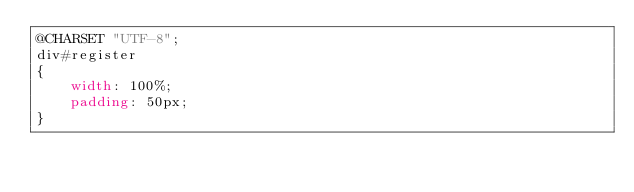<code> <loc_0><loc_0><loc_500><loc_500><_CSS_>@CHARSET "UTF-8";
div#register
{
	width: 100%;
	padding: 50px;
}</code> 